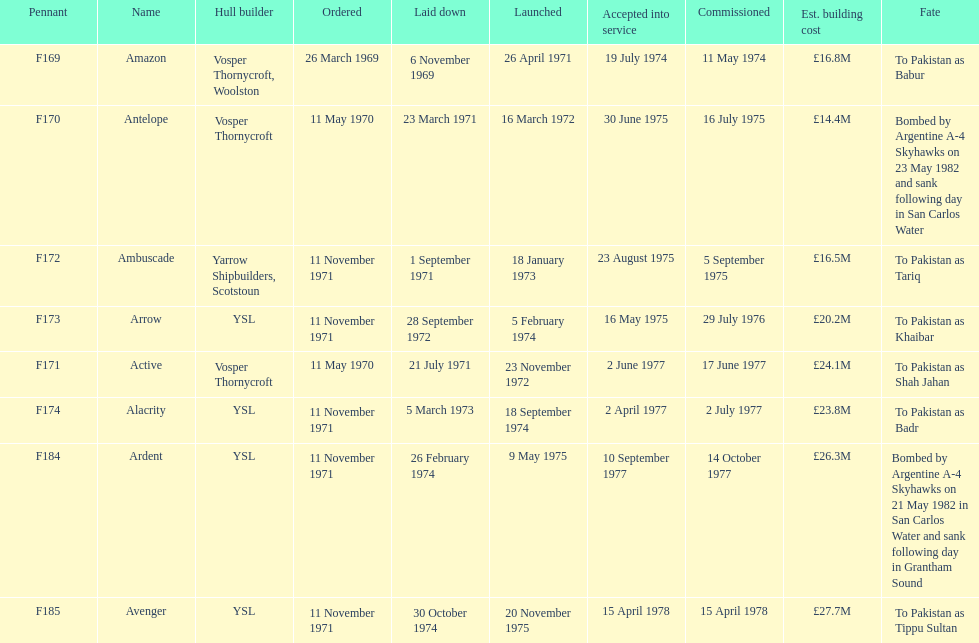Tell me the number of ships that went to pakistan. 6. 